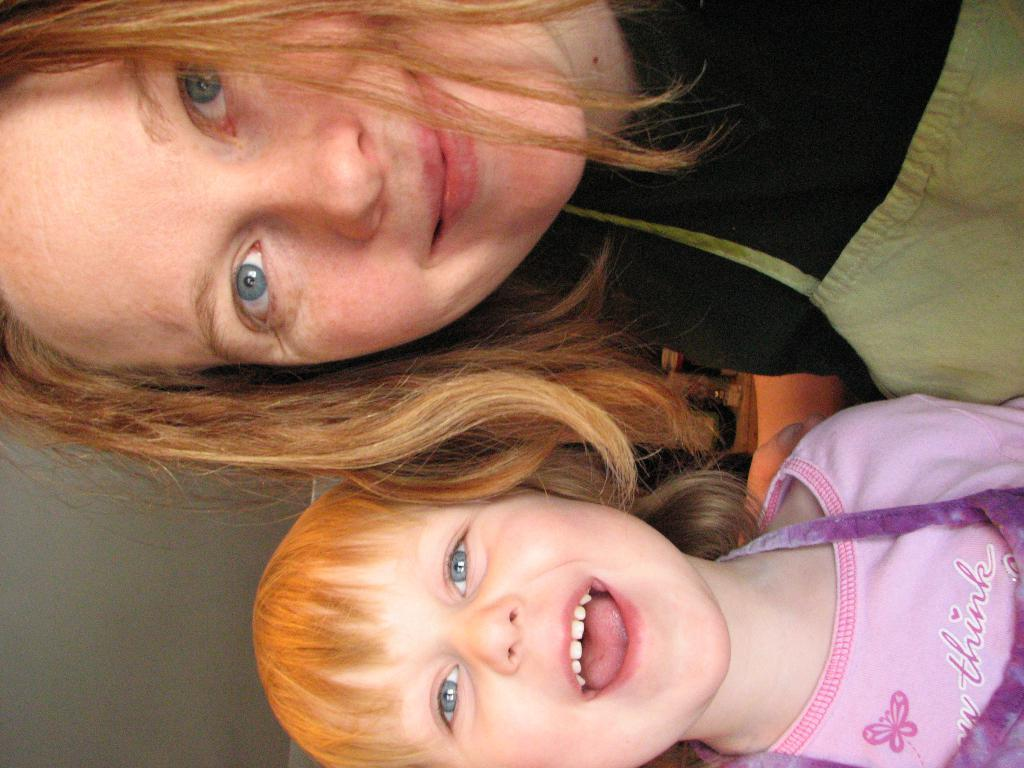Who is present in the image? There is a person in the image. What is the person wearing? The person is wearing clothes. Who else is present in the image? There is a kid in the image. What is the kid wearing? The kid is wearing clothes. Where is the bomb hidden in the image? There is no bomb present in the image. What type of stem can be seen growing from the person's clothes? There is no stem visible in the image. 